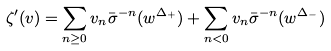Convert formula to latex. <formula><loc_0><loc_0><loc_500><loc_500>\zeta ^ { \prime } ( v ) = \sum _ { n \geq 0 } v _ { n } \bar { \sigma } ^ { - n } ( w ^ { \Delta _ { + } } ) + \sum _ { n < 0 } v _ { n } \bar { \sigma } ^ { - n } ( w ^ { \Delta _ { - } } )</formula> 